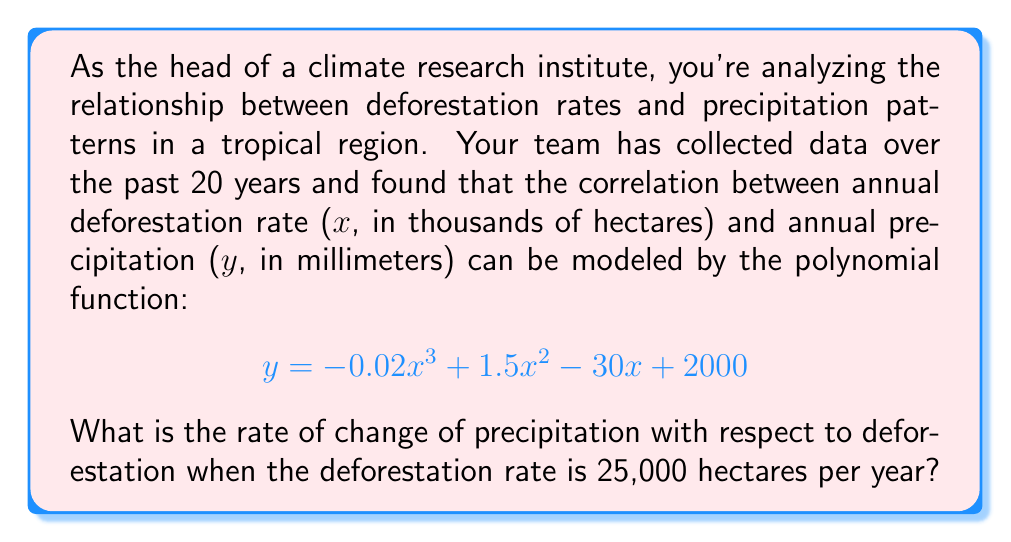Provide a solution to this math problem. To solve this problem, we need to follow these steps:

1) The rate of change of precipitation with respect to deforestation is given by the derivative of the function y with respect to x.

2) Let's find the derivative of the given function:
   $$ y = -0.02x^3 + 1.5x^2 - 30x + 2000 $$
   
   $$ \frac{dy}{dx} = -0.06x^2 + 3x - 30 $$

3) Now, we need to evaluate this derivative at x = 25 (since 25,000 hectares = 25 thousand hectares):

   $$ \frac{dy}{dx}\bigg|_{x=25} = -0.06(25)^2 + 3(25) - 30 $$

4) Let's calculate this step by step:
   $$ = -0.06(625) + 75 - 30 $$
   $$ = -37.5 + 75 - 30 $$
   $$ = 7.5 $$

5) Therefore, when the deforestation rate is 25,000 hectares per year, the rate of change of precipitation with respect to deforestation is 7.5 mm per thousand hectares.
Answer: 7.5 mm per thousand hectares 